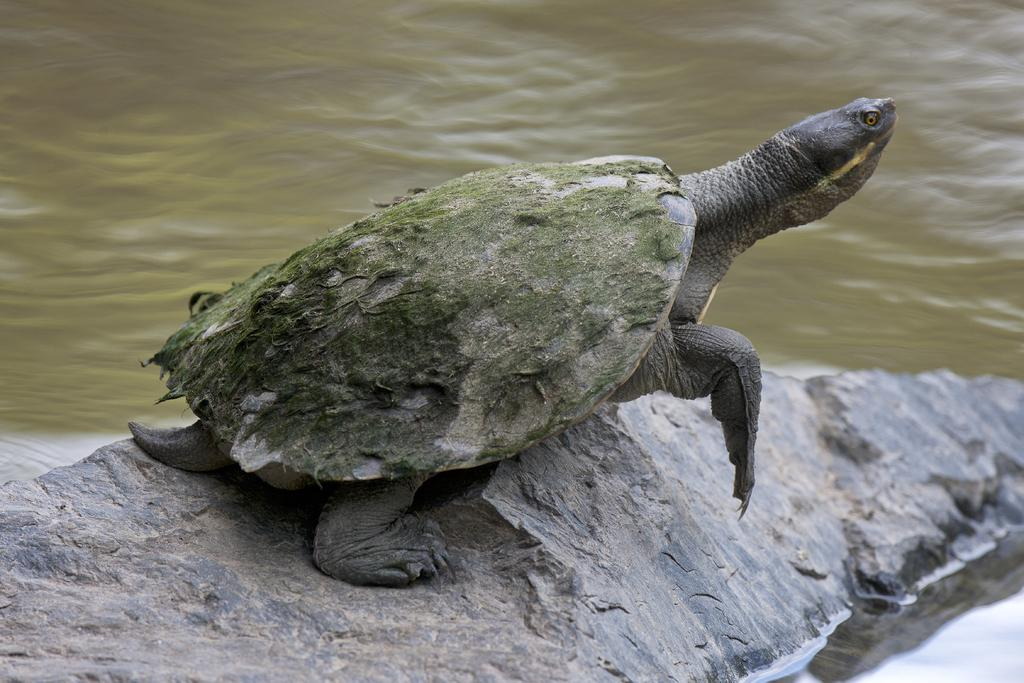What type of animal is in the image? There is a tortoise in the image. What other object can be seen in the image? There is a stone in the image. What is the third element present in the image? There is water in the image. How many tomatoes are on the wall in the image? There are no tomatoes or walls present in the image; it features a tortoise, a stone, and water. 